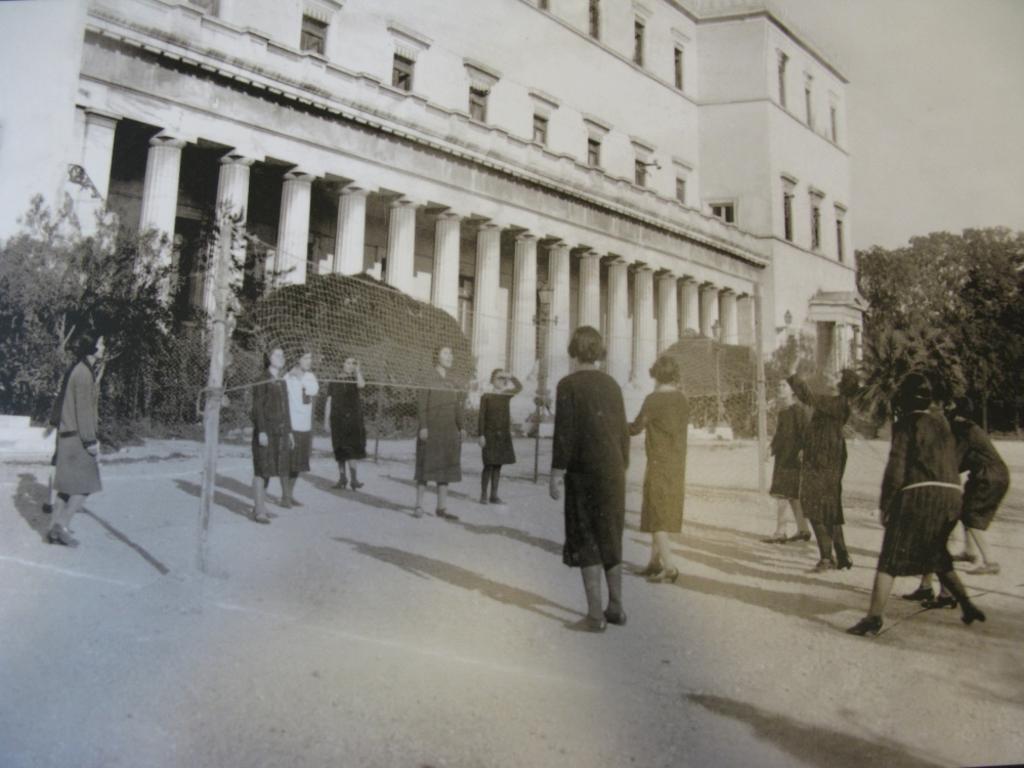Please provide a concise description of this image. In this image I can see few people are standing. I can see the building, pillars, windows, trees, sky and the net is attached to the poles. 